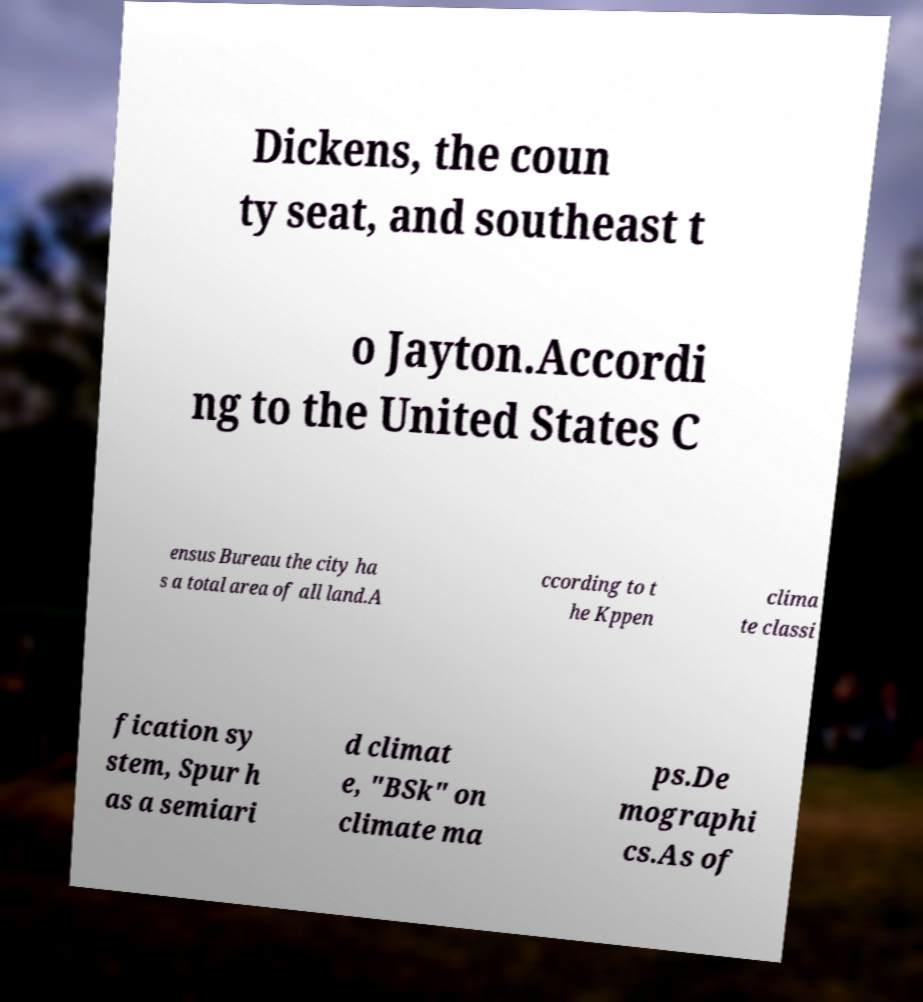There's text embedded in this image that I need extracted. Can you transcribe it verbatim? Dickens, the coun ty seat, and southeast t o Jayton.Accordi ng to the United States C ensus Bureau the city ha s a total area of all land.A ccording to t he Kppen clima te classi fication sy stem, Spur h as a semiari d climat e, "BSk" on climate ma ps.De mographi cs.As of 